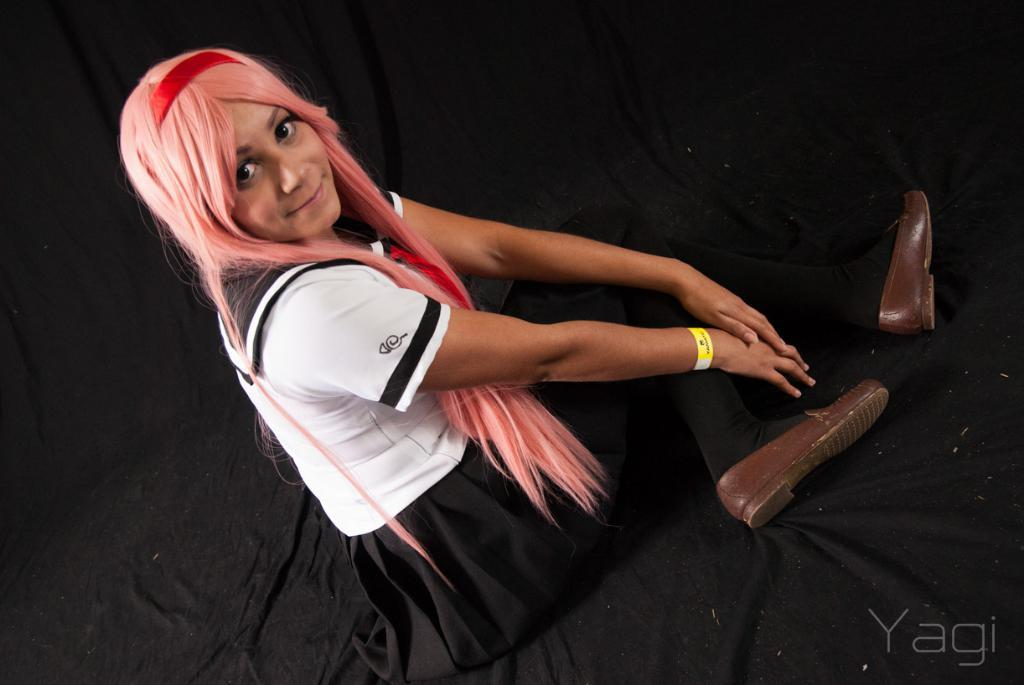Who is the main subject in the image? There is a girl in the image. What is the girl wearing? The girl is wearing a white and black dress. What is the girl's position in the image? The girl is sitting on the floor. What color is the cloth at the bottom of the image? The cloth at the bottom of the image is black. What is the color of the girl's hair? The girl's hair is pink. What type of voice can be heard coming from the girl in the image? There is no voice present in the image, as it is a still photograph. 